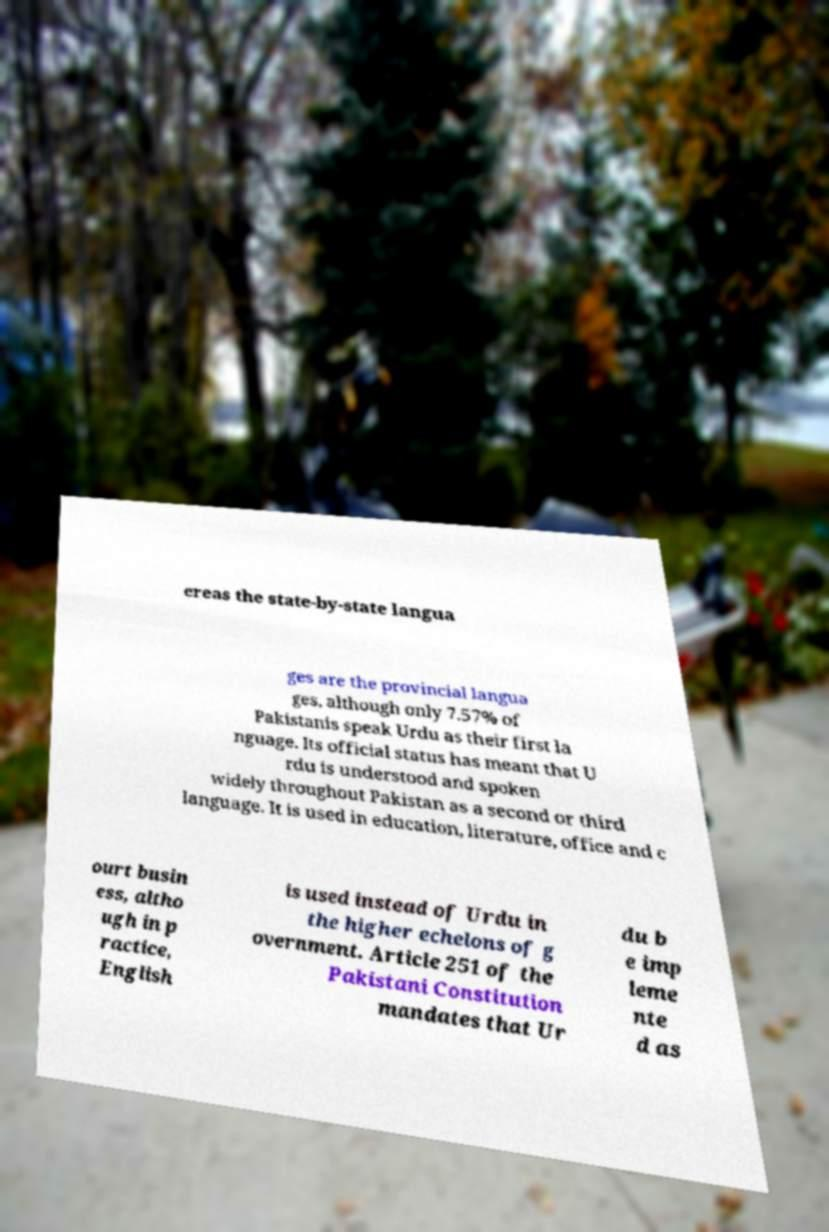Can you read and provide the text displayed in the image?This photo seems to have some interesting text. Can you extract and type it out for me? ereas the state-by-state langua ges are the provincial langua ges, although only 7.57% of Pakistanis speak Urdu as their first la nguage. Its official status has meant that U rdu is understood and spoken widely throughout Pakistan as a second or third language. It is used in education, literature, office and c ourt busin ess, altho ugh in p ractice, English is used instead of Urdu in the higher echelons of g overnment. Article 251 of the Pakistani Constitution mandates that Ur du b e imp leme nte d as 